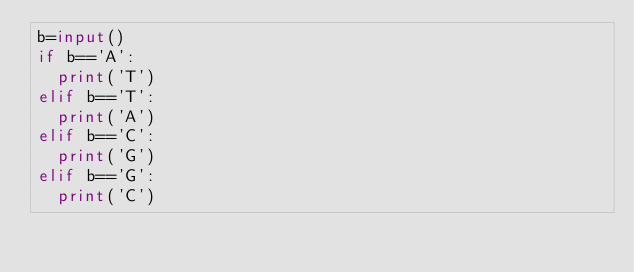Convert code to text. <code><loc_0><loc_0><loc_500><loc_500><_Python_>b=input()
if b=='A':
  print('T')
elif b=='T':
  print('A')
elif b=='C':
  print('G')
elif b=='G':
  print('C')
</code> 